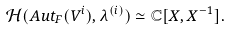<formula> <loc_0><loc_0><loc_500><loc_500>\mathcal { H } ( A u t _ { F } ( V ^ { i } ) , \lambda ^ { ( i ) } ) \simeq \mathbb { C } [ X , X ^ { - 1 } ] .</formula> 